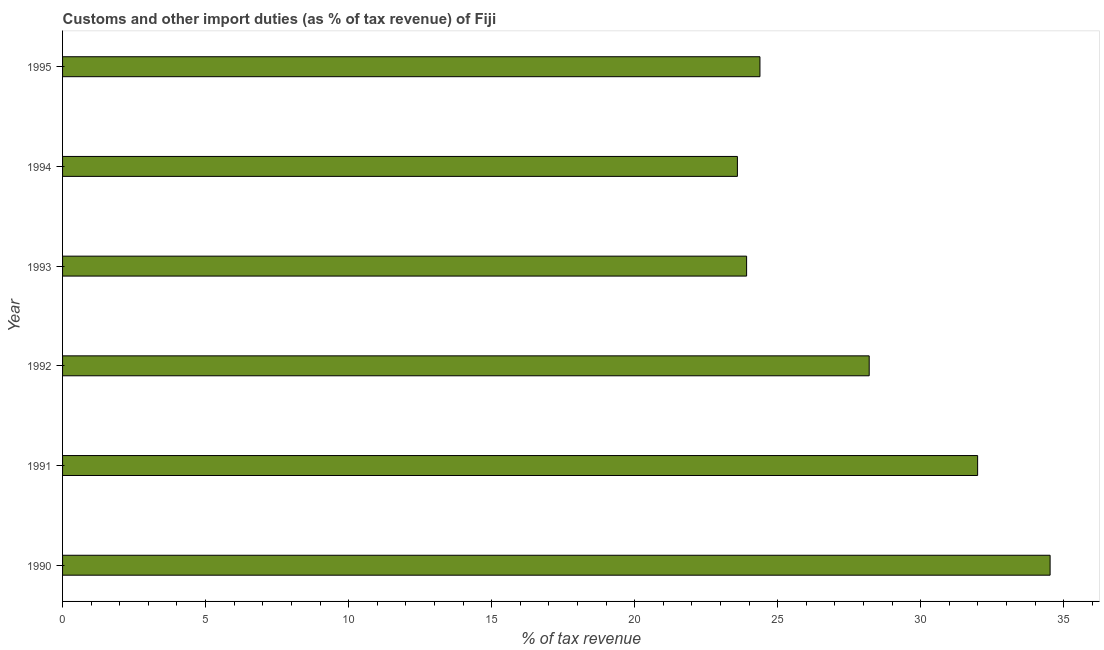Does the graph contain any zero values?
Offer a terse response. No. Does the graph contain grids?
Provide a succinct answer. No. What is the title of the graph?
Offer a terse response. Customs and other import duties (as % of tax revenue) of Fiji. What is the label or title of the X-axis?
Ensure brevity in your answer.  % of tax revenue. What is the label or title of the Y-axis?
Provide a short and direct response. Year. What is the customs and other import duties in 1992?
Make the answer very short. 28.2. Across all years, what is the maximum customs and other import duties?
Offer a terse response. 34.53. Across all years, what is the minimum customs and other import duties?
Keep it short and to the point. 23.59. In which year was the customs and other import duties maximum?
Your answer should be very brief. 1990. In which year was the customs and other import duties minimum?
Give a very brief answer. 1994. What is the sum of the customs and other import duties?
Offer a very short reply. 166.61. What is the difference between the customs and other import duties in 1992 and 1994?
Your answer should be very brief. 4.61. What is the average customs and other import duties per year?
Your answer should be compact. 27.77. What is the median customs and other import duties?
Provide a succinct answer. 26.29. In how many years, is the customs and other import duties greater than 23 %?
Keep it short and to the point. 6. What is the ratio of the customs and other import duties in 1990 to that in 1993?
Your answer should be very brief. 1.44. Is the customs and other import duties in 1990 less than that in 1993?
Your answer should be compact. No. What is the difference between the highest and the second highest customs and other import duties?
Your response must be concise. 2.53. Is the sum of the customs and other import duties in 1992 and 1993 greater than the maximum customs and other import duties across all years?
Keep it short and to the point. Yes. What is the difference between the highest and the lowest customs and other import duties?
Ensure brevity in your answer.  10.93. How many bars are there?
Give a very brief answer. 6. How many years are there in the graph?
Provide a succinct answer. 6. Are the values on the major ticks of X-axis written in scientific E-notation?
Your response must be concise. No. What is the % of tax revenue in 1990?
Offer a terse response. 34.53. What is the % of tax revenue in 1991?
Your answer should be very brief. 31.99. What is the % of tax revenue of 1992?
Ensure brevity in your answer.  28.2. What is the % of tax revenue in 1993?
Your response must be concise. 23.92. What is the % of tax revenue in 1994?
Your response must be concise. 23.59. What is the % of tax revenue of 1995?
Provide a short and direct response. 24.38. What is the difference between the % of tax revenue in 1990 and 1991?
Make the answer very short. 2.53. What is the difference between the % of tax revenue in 1990 and 1992?
Offer a very short reply. 6.32. What is the difference between the % of tax revenue in 1990 and 1993?
Keep it short and to the point. 10.61. What is the difference between the % of tax revenue in 1990 and 1994?
Keep it short and to the point. 10.93. What is the difference between the % of tax revenue in 1990 and 1995?
Offer a terse response. 10.14. What is the difference between the % of tax revenue in 1991 and 1992?
Keep it short and to the point. 3.79. What is the difference between the % of tax revenue in 1991 and 1993?
Give a very brief answer. 8.08. What is the difference between the % of tax revenue in 1991 and 1994?
Keep it short and to the point. 8.4. What is the difference between the % of tax revenue in 1991 and 1995?
Provide a succinct answer. 7.61. What is the difference between the % of tax revenue in 1992 and 1993?
Make the answer very short. 4.29. What is the difference between the % of tax revenue in 1992 and 1994?
Your answer should be compact. 4.61. What is the difference between the % of tax revenue in 1992 and 1995?
Offer a very short reply. 3.82. What is the difference between the % of tax revenue in 1993 and 1994?
Give a very brief answer. 0.32. What is the difference between the % of tax revenue in 1993 and 1995?
Your response must be concise. -0.47. What is the difference between the % of tax revenue in 1994 and 1995?
Offer a very short reply. -0.79. What is the ratio of the % of tax revenue in 1990 to that in 1991?
Offer a very short reply. 1.08. What is the ratio of the % of tax revenue in 1990 to that in 1992?
Ensure brevity in your answer.  1.22. What is the ratio of the % of tax revenue in 1990 to that in 1993?
Offer a terse response. 1.44. What is the ratio of the % of tax revenue in 1990 to that in 1994?
Make the answer very short. 1.46. What is the ratio of the % of tax revenue in 1990 to that in 1995?
Your answer should be very brief. 1.42. What is the ratio of the % of tax revenue in 1991 to that in 1992?
Provide a succinct answer. 1.13. What is the ratio of the % of tax revenue in 1991 to that in 1993?
Make the answer very short. 1.34. What is the ratio of the % of tax revenue in 1991 to that in 1994?
Provide a short and direct response. 1.36. What is the ratio of the % of tax revenue in 1991 to that in 1995?
Provide a short and direct response. 1.31. What is the ratio of the % of tax revenue in 1992 to that in 1993?
Provide a succinct answer. 1.18. What is the ratio of the % of tax revenue in 1992 to that in 1994?
Offer a terse response. 1.2. What is the ratio of the % of tax revenue in 1992 to that in 1995?
Your response must be concise. 1.16. What is the ratio of the % of tax revenue in 1993 to that in 1995?
Offer a terse response. 0.98. What is the ratio of the % of tax revenue in 1994 to that in 1995?
Offer a terse response. 0.97. 